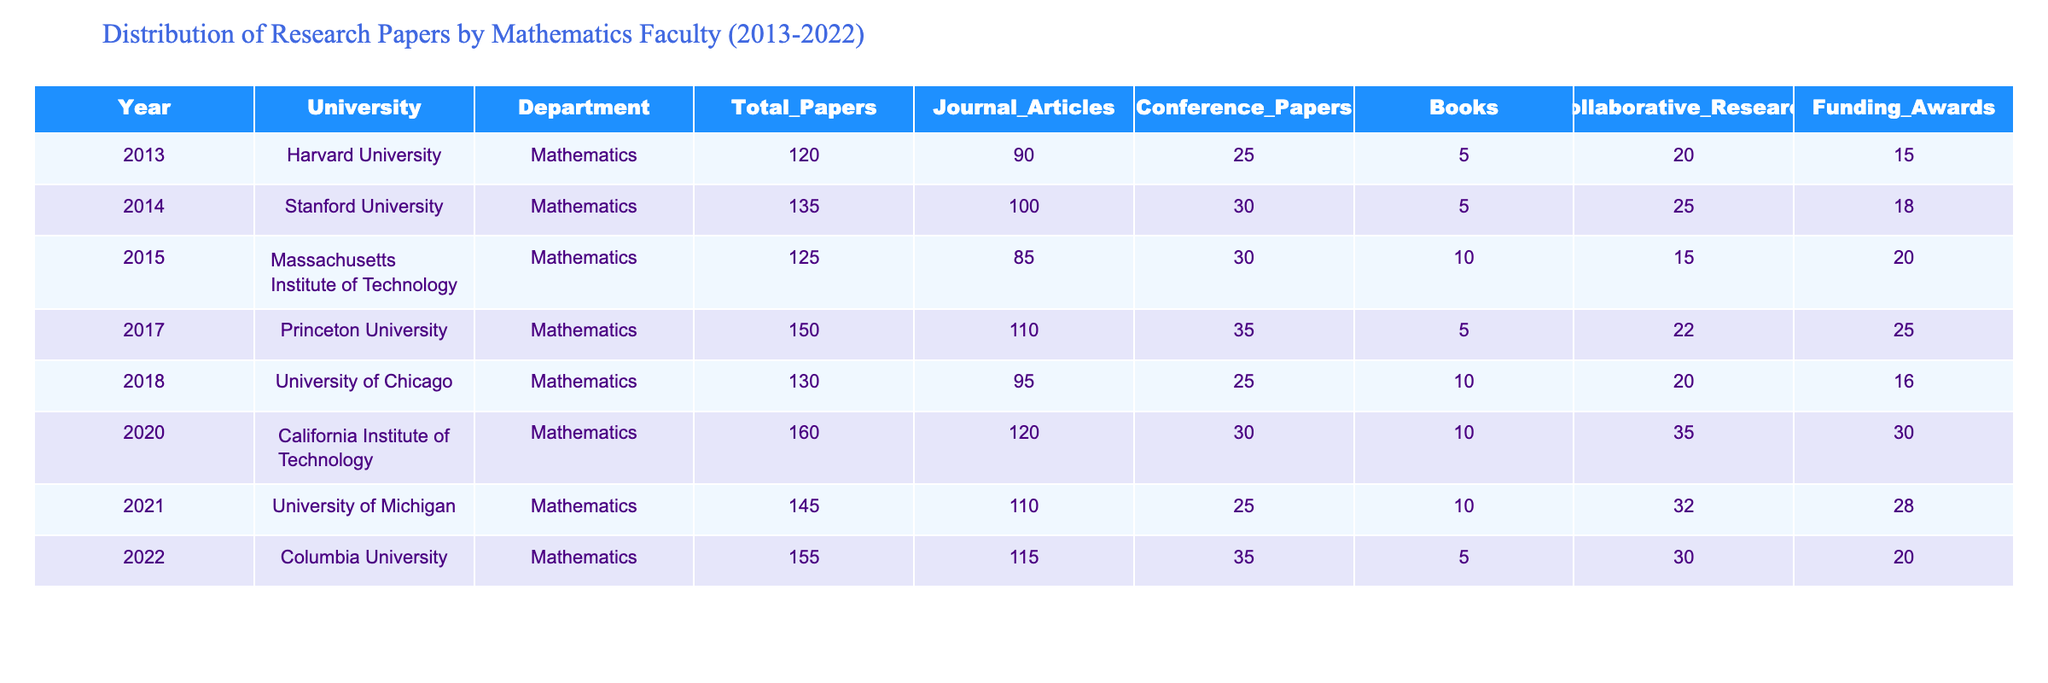What's the total number of research papers published at Harvard University in 2013? From the table, I can see that the total papers published at Harvard University in 2013 is listed as 120.
Answer: 120 Which university published the highest number of total papers in 2020? According to the table, California Institute of Technology published the highest number of total papers in 2020, which is 160.
Answer: California Institute of Technology What is the difference in the number of journal articles published between Stanford University in 2014 and Princeton University in 2017? The table shows that Stanford published 100 journal articles in 2014 and Princeton published 110 journal articles in 2017. The difference is 110 - 100 = 10.
Answer: 10 Calculate the average number of collaborative research projects across all universities from 2013 to 2022. First, I sum the collaborative research values: 20 + 25 + 15 + 22 + 20 + 35 + 32 + 30 = 199. There are 8 universities (years), so the average is 199 / 8 = 24.875.
Answer: 24.875 Is the total number of books published by the University of Chicago in 2018 greater than the total number of funding awards that year? The table indicates that University of Chicago published 10 books and received 16 funding awards in 2018. Since 10 is not greater than 16, the answer is no.
Answer: No Which year saw a decrease in total papers published compared to the previous year? Going through the table, I see that 2015 has a total of 125 papers, which is less than the 135 papers from 2014, indicating a decrease.
Answer: 2015 What is the sum of conference papers published by all universities in 2021 and 2022? From the table, the conference papers published in 2021 are 25 and in 2022 are 35. Adding these gives 25 + 35 = 60.
Answer: 60 Which department published a total of exactly 150 papers? Looking at the table, the total of 150 papers was published by Princeton University in 2017.
Answer: Princeton University in 2017 Calculate the percentage of journal articles to total papers published by the Massachusetts Institute of Technology in 2015. MIT published 125 total papers and 85 were journal articles. The percentage is (85 / 125) * 100 = 68%.
Answer: 68% Which university, during the period shown, had the highest number of funding awards in a single year? The table shows that California Institute of Technology received the highest number of funding awards at 30 in 2020.
Answer: California Institute of Technology in 2020 